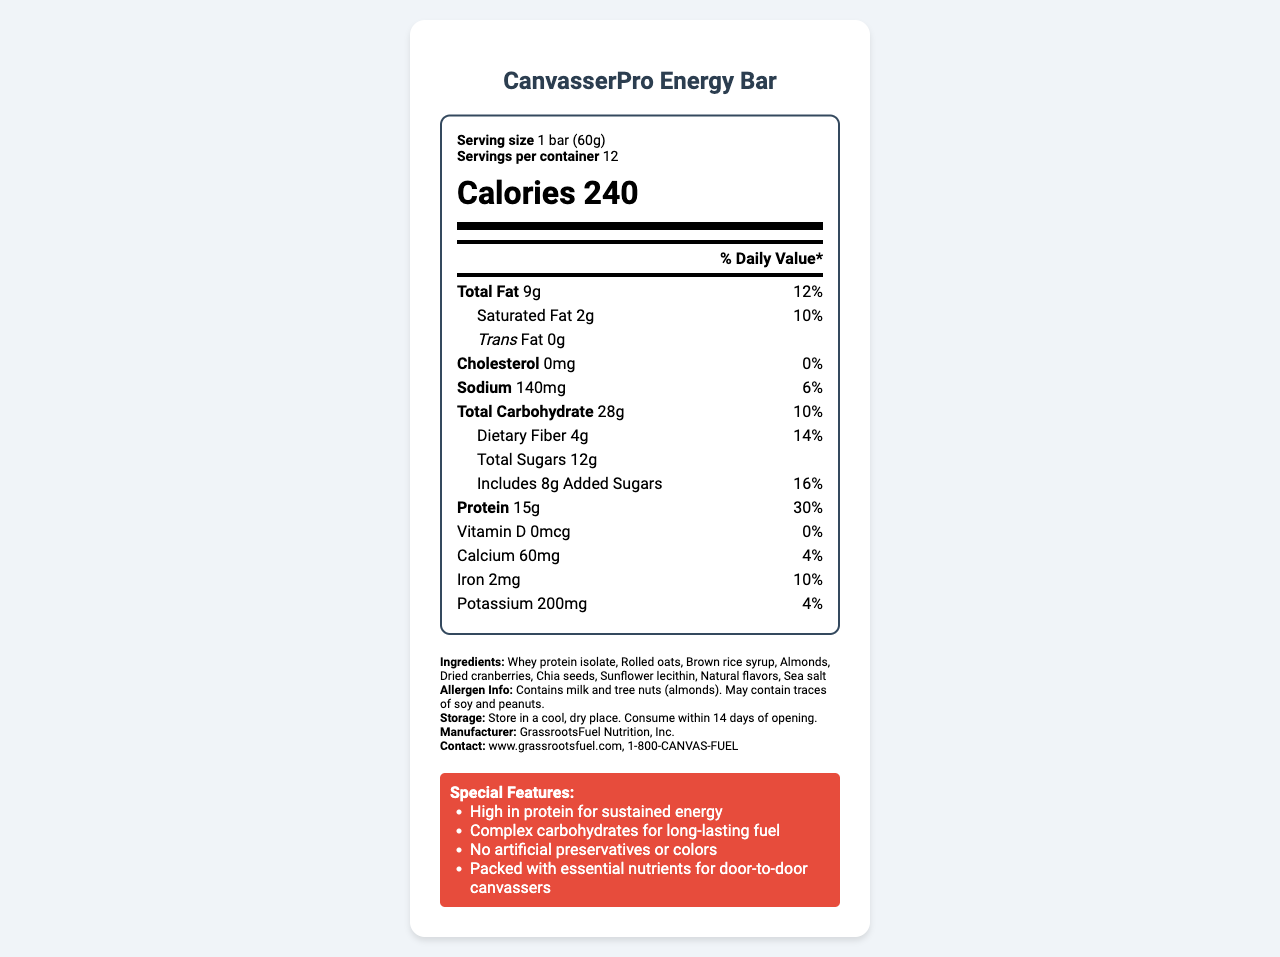how many calories are in one serving of the CanvasserPro Energy Bar? The nutrition label specifies that each serving contains 240 calories.
Answer: 240 what is the serving size mentioned on the label? The label mentions the serving size as 1 bar (60g).
Answer: 1 bar (60g) what percentage of the daily value of protein does one energy bar provide? The label indicates that each bar provides 15g of protein, which is 30% of the daily value.
Answer: 30% how much dietary fiber is in one serving? The nutrition label states that one serving contains 4g of dietary fiber.
Answer: 4g what are the total carbohydrates per serving? The label lists 28g of total carbohydrates per serving.
Answer: 28g what is the main allergen information provided on the label? The label clearly mentions that the product contains milk and tree nuts (almonds) and may contain traces of soy and peanuts.
Answer: Contains milk and tree nuts (almonds). May contain traces of soy and peanuts. how much calcium is in one serving of the bar? According to the nutrition label, each serving contains 60mg of calcium.
Answer: 60mg what are the special features of the CanvasserPro Energy Bar? A. High in protein, B. Complex carbs, C. No artificial preservatives/colors, D. All of the above The special features list mentions that the bar is high in protein, has complex carbohydrates, and contains no artificial preservatives or colors.
Answer: D. All of the above what is the sodium content per serving? A. 140mg B. 120mg C. 150mg The nutrition label specifies that each serving contains 140mg of sodium.
Answer: A. 140mg how many servings are in a container? A. 12 B. 10 C. 14 D. 8 The label states that there are 12 servings per container.
Answer: A. 12 does this product contain trans fat? The label indicates that there is 0g of trans fat per serving.
Answer: No what would be a good summary of the CanvasserPro Energy Bar's nutrition facts and features? The bar offers a balanced nutritional profile with high protein and carbs for sustained energy, designed specifically for canvassers, while also detailing allergen information and storage instructions.
Answer: The CanvasserPro Energy Bar provides 240 calories per serving, with 15g of protein (30% DV), 28g of carbs, and 9g of total fat. It is high in protein, contains complex carbs, and has no artificial preservatives or colors. It is suitable for door-to-door canvassers and contains allergens like milk and tree nuts. who is the manufacturer of the energy bar? The manufacturer of the energy bar is listed as GrassrootsFuel Nutrition, Inc.
Answer: GrassrootsFuel Nutrition, Inc. what is the exact amount of iron per serving? The label specifies that each serving contains 2mg of iron.
Answer: 2mg how can one contact the manufacturer for more information? The contact information for the manufacturer is provided on the label as www.grassrootsfuel.com and 1-800-CANVAS-FUEL.
Answer: www.grassrootsfuel.com, 1-800-CANVAS-FUEL what are the primary protein source and the types of carbohydrates used in the energy bar? The ingredient list mentions whey protein isolate as the primary protein source, with rolled oats and brown rice syrup as the carbohydrate sources.
Answer: Whey protein isolate, Rolled oats, and Brown rice syrup will the energy bar help achieve 100% of the daily value of vitamin D? The label indicates that the energy bar contains 0mcg of vitamin D, which is 0% of the daily value.
Answer: No what's the storage instruction for the CanvasserPro Energy Bar? The label advises to store the bar in a cool, dry place and consume it within 14 days of opening.
Answer: Store in a cool, dry place. Consume within 14 days of opening. does the CanvasserPro Energy Bar contain any artificial preservatives or colors? The label lists "No artificial preservatives or colors" as one of the special features.
Answer: No are chia seeds included in the ingredients? The ingredient list confirms the presence of chia seeds in the bar.
Answer: Yes is the amount of potassium mentioned? The nutrition label indicates that there are 200mg of potassium per serving.
Answer: Yes, it is 200mg. what flavors are used in the CanvasserPro Energy Bar? The ingredient list mentions "Natural flavors" as part of the energy bar.
Answer: Natural flavors how long will the CanvasserPro Energy Bar last after opening? The label instructs consumers to consume the bar within 14 days of opening.
Answer: 14 days can the exact percentage of daily value for potassium be determined from the label? The label provides the amount of potassium (200mg) but does not specify the percentage of the daily value.
Answer: No what is the main function of the CanvasserPro Energy Bar as per the special features? The special features section highlights that the bar is high in protein, which helps with sustained energy release, making it suitable for door-to-door canvassing.
Answer: High in protein for sustained energy 